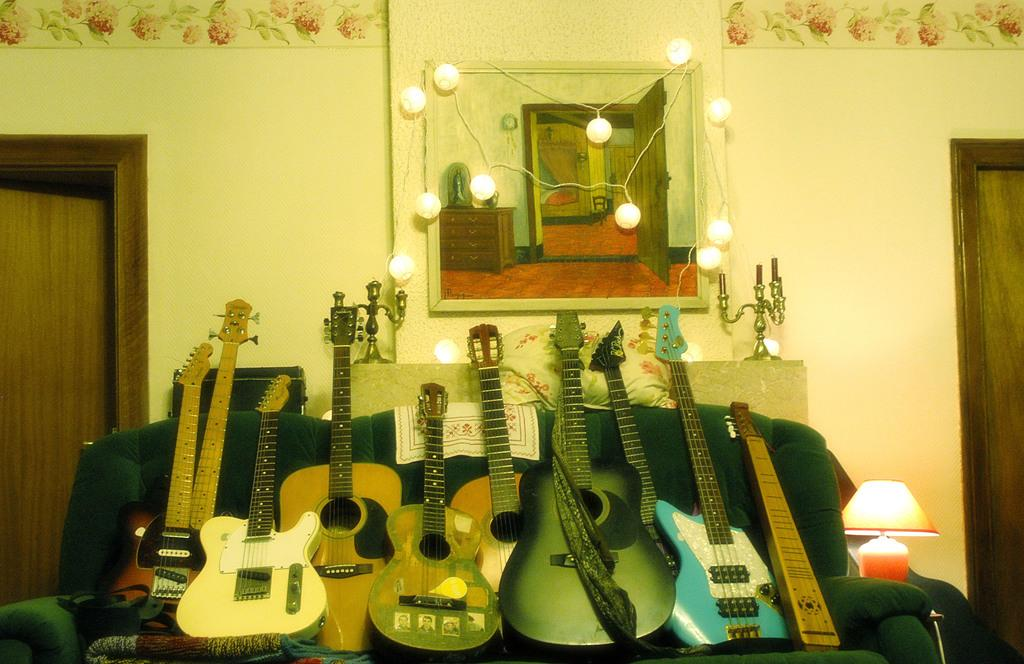What musical instruments are present in the image? There are guitars in the image. Where are the guitars placed in the image? The guitars are placed on a sofa. What type of room is depicted in the image? The location is a living room. Can you see a donkey on the shelf in the image? There is no shelf or donkey present in the image. 